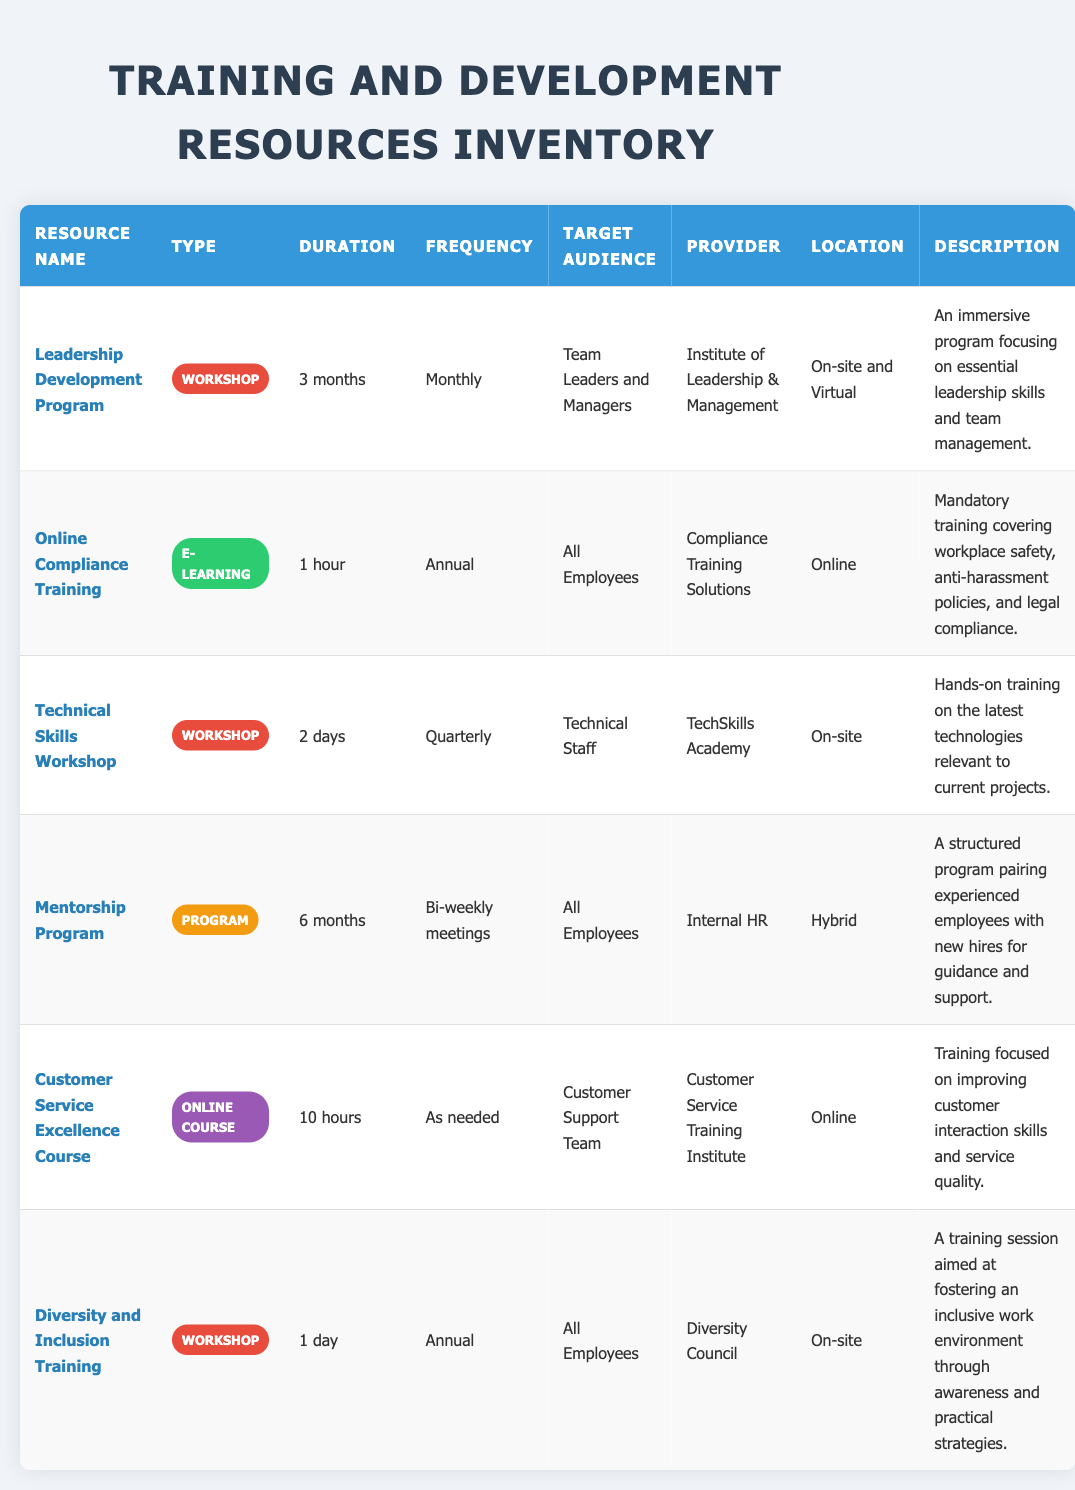What is the duration of the Leadership Development Program? The duration is listed directly in the table under the "Duration" column for the resource "Leadership Development Program"
Answer: 3 months How often is the Online Compliance Training provided? The frequency of the Online Compliance Training can be found in the "Frequency" column, which states that it is conducted annually
Answer: Annual Is the Mentorship Program available for all employees? The target audience for the Mentorship Program is specified in the table and it indicates that it is available for all employees
Answer: Yes Which training resource requires the longest duration? To identify the resource with the longest duration, we compare the durations in the "Duration" column. The "Mentorship Program" at 6 months is the longest
Answer: Mentorship Program How many total hours of training does the Customer Service Excellence Course offer? The "Duration" for the Customer Service Excellence Course states it is 10 hours, which is a clear numeric value to retrieve
Answer: 10 hours Are diversity training and compliance training types of workshops? The type of each training resource is compared; Diversity and Inclusion Training is a workshop, but Online Compliance Training is an E-Learning course, therefore the statement is false
Answer: No What is the average duration of the training resources listed in the table? To find the average, convert the duration of each resource into a comparable format. The durations in months or hours are: Leadership Development Program (3 months), Online Compliance Training (1 hour), Technical Skills Workshop (2 days, converted to 0.067 months), Mentorship Program (6 months), Customer Service Excellence Course (10 hours, converted to 0.0278 months), and Diversity and Inclusion Training (1 day, converted to 0.0333 months). The total is approximately 9.27 months. There are 6 training resources, thus the average is 9.27 / 6 = 1.545
Answer: Approximately 1.55 months Which provider offers the Technical Skills Workshop? The information can be found straightforwardly in the table under "Provider," specifically for the row corresponding to Technical Skills Workshop
Answer: TechSkills Academy What types of training resources are offered online? To answer this, check the "Type" and "Location" columns for training resources listed as providing online access. The "Online Compliance Training", "Customer Service Excellence Course", and the "Mentorship Program" are all offered online (note: mentorship is hybrid)
Answer: 2 (strictly online resources) 